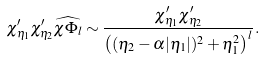<formula> <loc_0><loc_0><loc_500><loc_500>\chi _ { \eta _ { 1 } } ^ { \prime } \chi _ { \eta _ { 2 } } ^ { \prime } \widehat { \chi \Phi _ { l } } \sim \frac { \chi _ { \eta _ { 1 } } ^ { \prime } \chi _ { \eta _ { 2 } } ^ { \prime } } { { \left ( ( \eta _ { 2 } - \alpha | \eta _ { 1 } | ) ^ { 2 } + \eta _ { 1 } ^ { 2 } \right ) ^ { l } } } .</formula> 